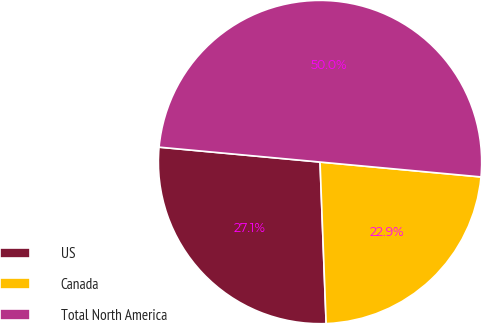Convert chart. <chart><loc_0><loc_0><loc_500><loc_500><pie_chart><fcel>US<fcel>Canada<fcel>Total North America<nl><fcel>27.07%<fcel>22.93%<fcel>50.0%<nl></chart> 